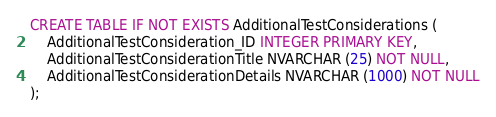<code> <loc_0><loc_0><loc_500><loc_500><_SQL_>CREATE TABLE IF NOT EXISTS AdditionalTestConsiderations (
    AdditionalTestConsideration_ID INTEGER PRIMARY KEY,
    AdditionalTestConsiderationTitle NVARCHAR (25) NOT NULL,
    AdditionalTestConsiderationDetails NVARCHAR (1000) NOT NULL
);</code> 